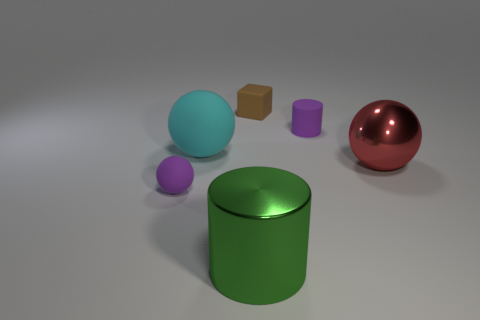What is the size of the cylinder that is the same color as the small sphere?
Your answer should be very brief. Small. Are there fewer metal balls behind the red metallic sphere than balls?
Give a very brief answer. Yes. What color is the big object that is in front of the large matte object and to the left of the large red object?
Your answer should be very brief. Green. What number of other objects are there of the same shape as the big red object?
Keep it short and to the point. 2. Is the number of balls that are on the right side of the small purple sphere less than the number of small cubes right of the purple rubber cylinder?
Keep it short and to the point. No. Is the large red thing made of the same material as the cylinder right of the block?
Keep it short and to the point. No. Is there any other thing that has the same material as the small ball?
Your answer should be compact. Yes. Are there more large purple shiny cylinders than brown things?
Give a very brief answer. No. What shape is the shiny thing that is behind the big shiny object in front of the tiny purple matte thing that is in front of the big matte ball?
Provide a short and direct response. Sphere. Is the purple object in front of the metallic sphere made of the same material as the large ball that is to the left of the tiny block?
Ensure brevity in your answer.  Yes. 